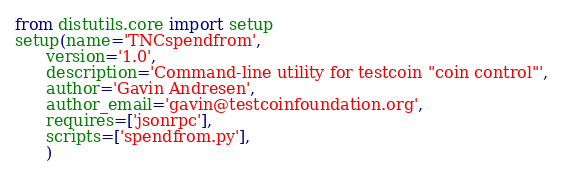<code> <loc_0><loc_0><loc_500><loc_500><_Python_>from distutils.core import setup
setup(name='TNCspendfrom',
      version='1.0',
      description='Command-line utility for testcoin "coin control"',
      author='Gavin Andresen',
      author_email='gavin@testcoinfoundation.org',
      requires=['jsonrpc'],
      scripts=['spendfrom.py'],
      )
</code> 